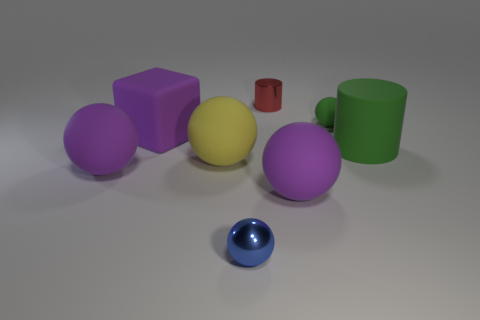Subtract all green spheres. How many spheres are left? 4 Subtract all large yellow balls. How many balls are left? 4 Subtract 2 spheres. How many spheres are left? 3 Subtract all brown balls. Subtract all green cylinders. How many balls are left? 5 Add 2 big purple balls. How many objects exist? 10 Subtract all blocks. How many objects are left? 7 Subtract 0 blue cylinders. How many objects are left? 8 Subtract all big green rubber things. Subtract all tiny red objects. How many objects are left? 6 Add 7 big cylinders. How many big cylinders are left? 8 Add 6 big yellow things. How many big yellow things exist? 7 